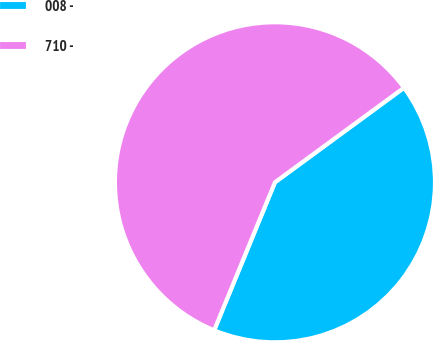<chart> <loc_0><loc_0><loc_500><loc_500><pie_chart><fcel>008 -<fcel>710 -<nl><fcel>41.27%<fcel>58.73%<nl></chart> 